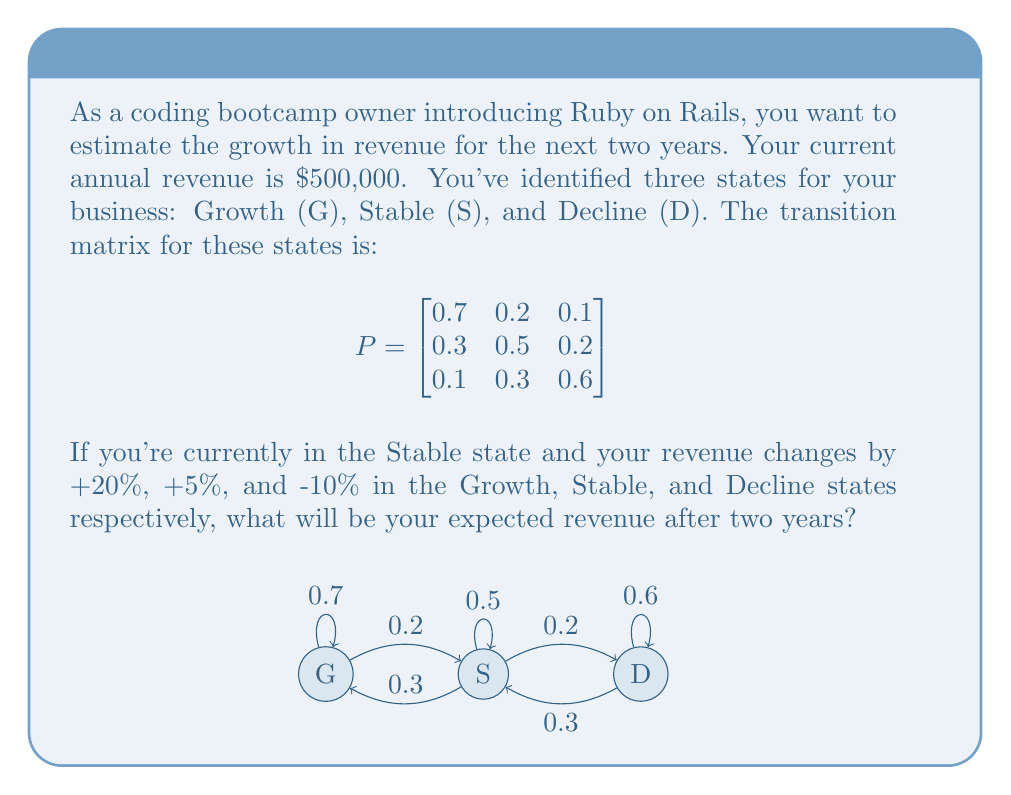Solve this math problem. Let's approach this step-by-step:

1) First, we need to calculate the probability distribution after two years, starting from the Stable state. The initial state vector is:

   $$v_0 = \begin{bmatrix} 0 & 1 & 0 \end{bmatrix}$$

2) We can calculate the state after two years by multiplying this vector by the transition matrix twice:

   $$v_2 = v_0 \cdot P^2$$

3) Let's calculate $P^2$:

   $$P^2 = \begin{bmatrix}
   0.7 & 0.2 & 0.1 \\
   0.3 & 0.5 & 0.2 \\
   0.1 & 0.3 & 0.6
   \end{bmatrix} \cdot \begin{bmatrix}
   0.7 & 0.2 & 0.1 \\
   0.3 & 0.5 & 0.2 \\
   0.1 & 0.3 & 0.6
   \end{bmatrix} = \begin{bmatrix}
   0.56 & 0.29 & 0.15 \\
   0.37 & 0.41 & 0.22 \\
   0.22 & 0.37 & 0.41
   \end{bmatrix}$$

4) Now we can calculate $v_2$:

   $$v_2 = \begin{bmatrix} 0 & 1 & 0 \end{bmatrix} \cdot \begin{bmatrix}
   0.56 & 0.29 & 0.15 \\
   0.37 & 0.41 & 0.22 \\
   0.22 & 0.37 & 0.41
   \end{bmatrix} = \begin{bmatrix} 0.37 & 0.41 & 0.22 \end{bmatrix}$$

5) This means after two years, the probabilities of being in Growth, Stable, and Decline states are 0.37, 0.41, and 0.22 respectively.

6) Now, let's calculate the expected revenue change:

   Growth: 0.37 * 20% = 7.4%
   Stable: 0.41 * 5% = 2.05%
   Decline: 0.22 * (-10%) = -2.2%

   Total expected change: 7.4% + 2.05% - 2.2% = 7.25%

7) Starting from $500,000, a 7.25% increase would result in:

   $500,000 * (1 + 0.0725) = $536,250$
Answer: $536,250 